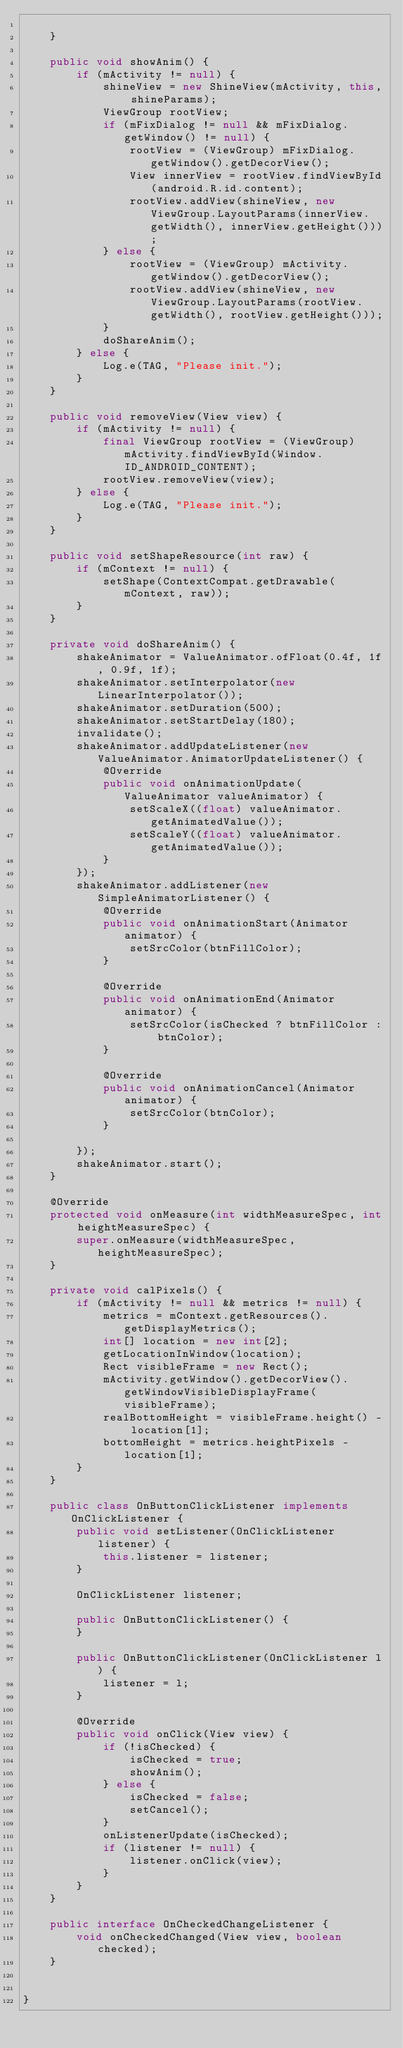Convert code to text. <code><loc_0><loc_0><loc_500><loc_500><_Java_>
    }

    public void showAnim() {
        if (mActivity != null) {
            shineView = new ShineView(mActivity, this, shineParams);
            ViewGroup rootView;
            if (mFixDialog != null && mFixDialog.getWindow() != null) {
                rootView = (ViewGroup) mFixDialog.getWindow().getDecorView();
                View innerView = rootView.findViewById(android.R.id.content);
                rootView.addView(shineView, new ViewGroup.LayoutParams(innerView.getWidth(), innerView.getHeight()));
            } else {
                rootView = (ViewGroup) mActivity.getWindow().getDecorView();
                rootView.addView(shineView, new ViewGroup.LayoutParams(rootView.getWidth(), rootView.getHeight()));
            }
            doShareAnim();
        } else {
            Log.e(TAG, "Please init.");
        }
    }

    public void removeView(View view) {
        if (mActivity != null) {
            final ViewGroup rootView = (ViewGroup) mActivity.findViewById(Window.ID_ANDROID_CONTENT);
            rootView.removeView(view);
        } else {
            Log.e(TAG, "Please init.");
        }
    }

    public void setShapeResource(int raw) {
        if (mContext != null) {
            setShape(ContextCompat.getDrawable(mContext, raw));
        }
    }

    private void doShareAnim() {
        shakeAnimator = ValueAnimator.ofFloat(0.4f, 1f, 0.9f, 1f);
        shakeAnimator.setInterpolator(new LinearInterpolator());
        shakeAnimator.setDuration(500);
        shakeAnimator.setStartDelay(180);
        invalidate();
        shakeAnimator.addUpdateListener(new ValueAnimator.AnimatorUpdateListener() {
            @Override
            public void onAnimationUpdate(ValueAnimator valueAnimator) {
                setScaleX((float) valueAnimator.getAnimatedValue());
                setScaleY((float) valueAnimator.getAnimatedValue());
            }
        });
        shakeAnimator.addListener(new SimpleAnimatorListener() {
            @Override
            public void onAnimationStart(Animator animator) {
                setSrcColor(btnFillColor);
            }

            @Override
            public void onAnimationEnd(Animator animator) {
                setSrcColor(isChecked ? btnFillColor : btnColor);
            }

            @Override
            public void onAnimationCancel(Animator animator) {
                setSrcColor(btnColor);
            }

        });
        shakeAnimator.start();
    }

    @Override
    protected void onMeasure(int widthMeasureSpec, int heightMeasureSpec) {
        super.onMeasure(widthMeasureSpec, heightMeasureSpec);
    }

    private void calPixels() {
        if (mActivity != null && metrics != null) {
            metrics = mContext.getResources().getDisplayMetrics();
            int[] location = new int[2];
            getLocationInWindow(location);
            Rect visibleFrame = new Rect();
            mActivity.getWindow().getDecorView().getWindowVisibleDisplayFrame(visibleFrame);
            realBottomHeight = visibleFrame.height() - location[1];
            bottomHeight = metrics.heightPixels - location[1];
        }
    }

    public class OnButtonClickListener implements OnClickListener {
        public void setListener(OnClickListener listener) {
            this.listener = listener;
        }

        OnClickListener listener;

        public OnButtonClickListener() {
        }

        public OnButtonClickListener(OnClickListener l) {
            listener = l;
        }

        @Override
        public void onClick(View view) {
            if (!isChecked) {
                isChecked = true;
                showAnim();
            } else {
                isChecked = false;
                setCancel();
            }
            onListenerUpdate(isChecked);
            if (listener != null) {
                listener.onClick(view);
            }
        }
    }

    public interface OnCheckedChangeListener {
        void onCheckedChanged(View view, boolean checked);
    }


}</code> 